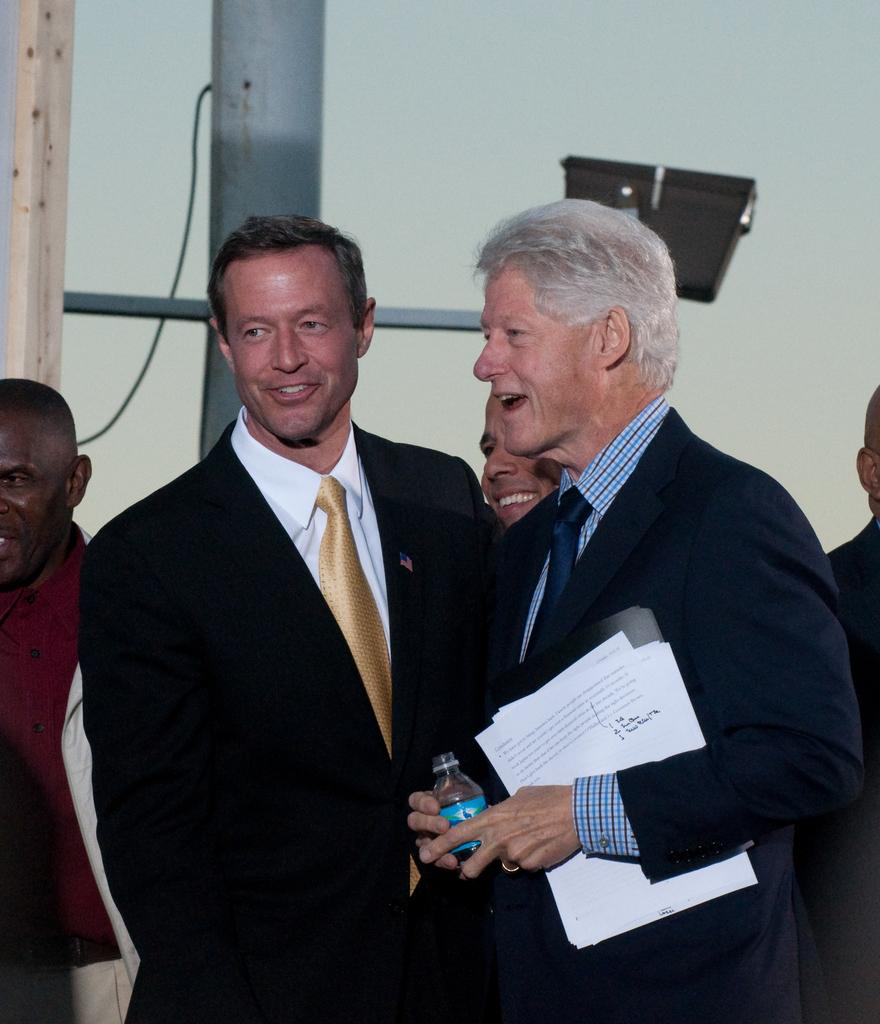How many people are in the image? There is a group of people in the image. What are the people wearing? The people are wearing different color dresses. What objects are being held by the people? One person is holding a bottle, and another person is holding a paper. What can be seen in the background of the image? There is a pole and a wall in the background of the image. What type of verse can be heard being recited by the crow in the image? There is no crow present in the image, and therefore no such activity can be observed. 